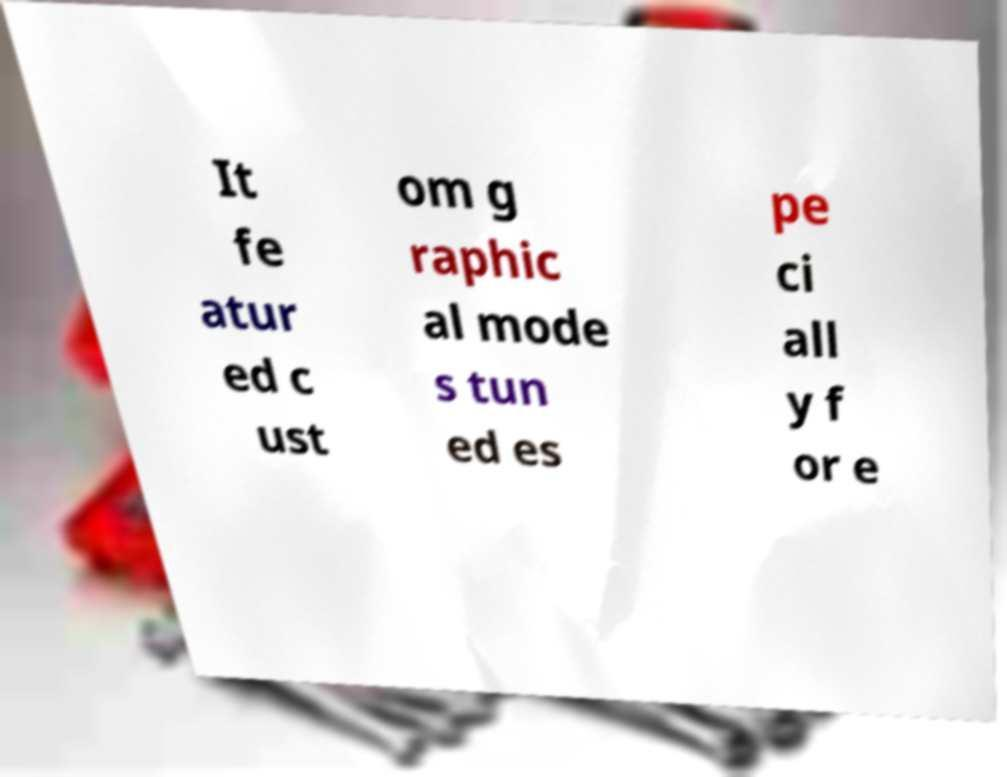Could you extract and type out the text from this image? It fe atur ed c ust om g raphic al mode s tun ed es pe ci all y f or e 